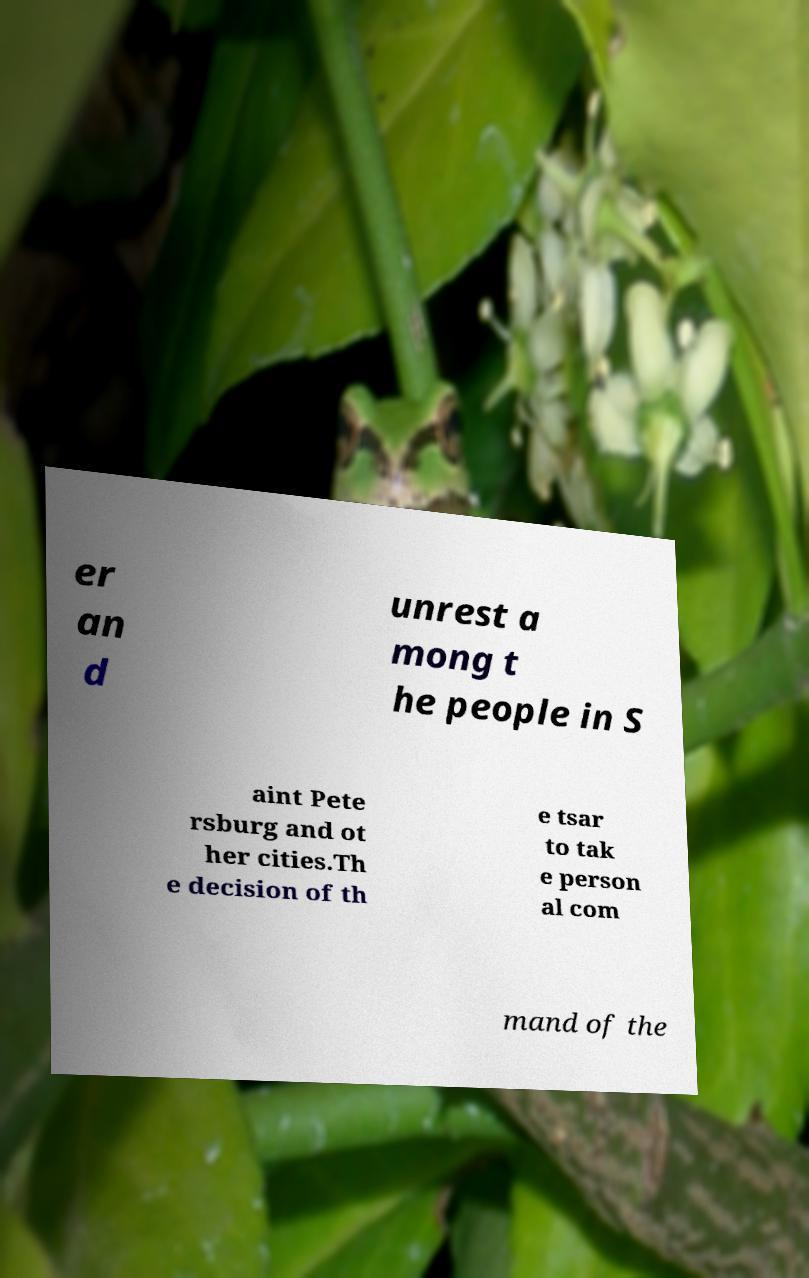Could you assist in decoding the text presented in this image and type it out clearly? er an d unrest a mong t he people in S aint Pete rsburg and ot her cities.Th e decision of th e tsar to tak e person al com mand of the 